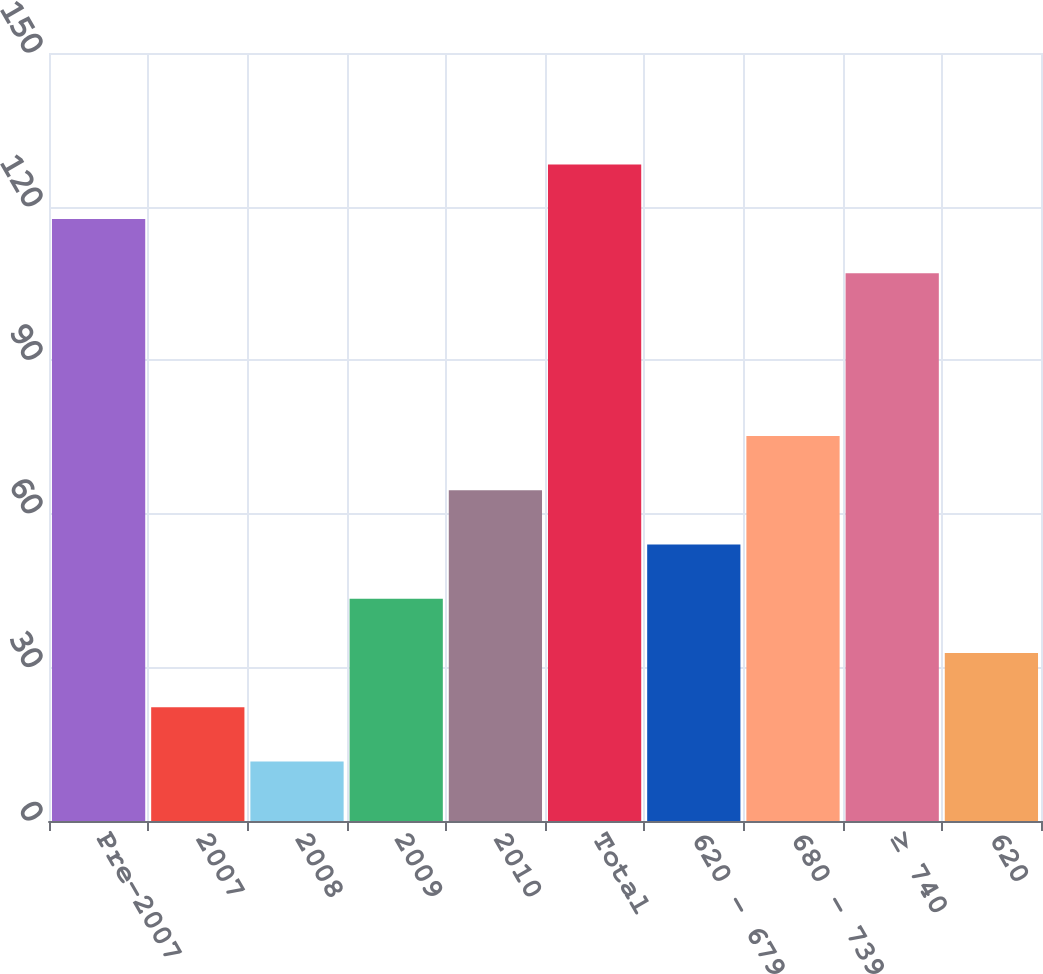<chart> <loc_0><loc_0><loc_500><loc_500><bar_chart><fcel>Pre-2007<fcel>2007<fcel>2008<fcel>2009<fcel>2010<fcel>Total<fcel>620 - 679<fcel>680 - 739<fcel>≥ 740<fcel>620<nl><fcel>117.6<fcel>22.2<fcel>11.6<fcel>43.4<fcel>64.6<fcel>128.2<fcel>54<fcel>75.2<fcel>107<fcel>32.8<nl></chart> 